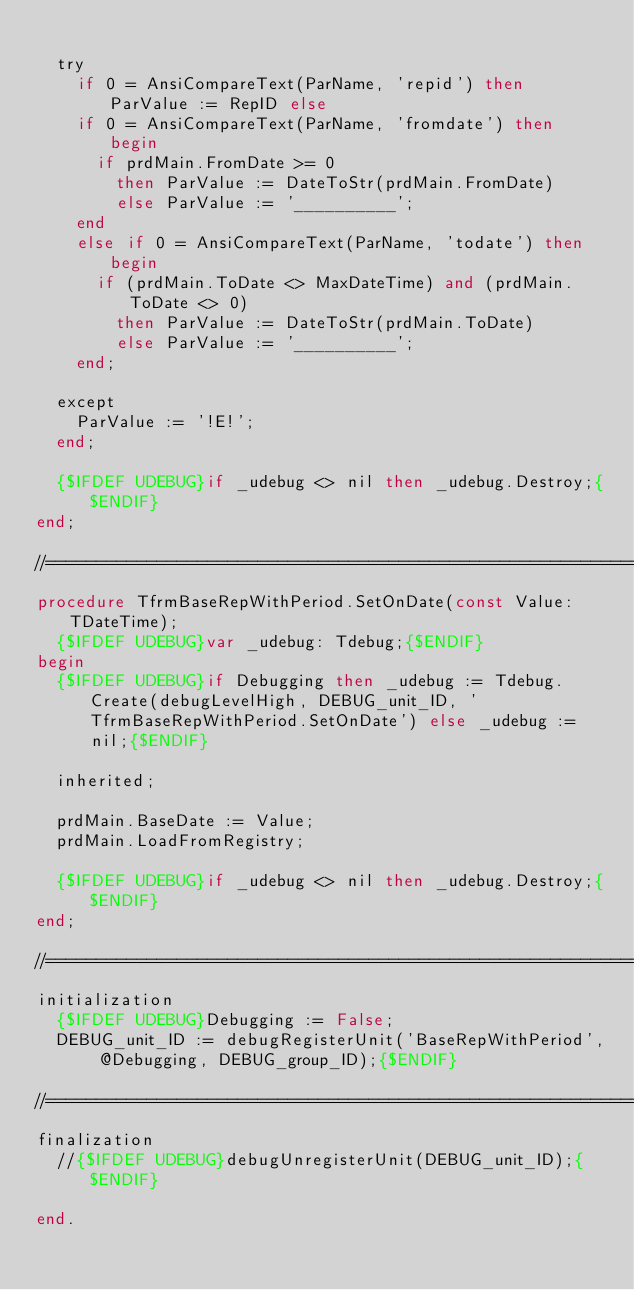Convert code to text. <code><loc_0><loc_0><loc_500><loc_500><_Pascal_>
  try
    if 0 = AnsiCompareText(ParName, 'repid') then ParValue := RepID else
    if 0 = AnsiCompareText(ParName, 'fromdate') then begin
      if prdMain.FromDate >= 0
        then ParValue := DateToStr(prdMain.FromDate)
        else ParValue := '__________';
    end
    else if 0 = AnsiCompareText(ParName, 'todate') then begin
      if (prdMain.ToDate <> MaxDateTime) and (prdMain.ToDate <> 0)
        then ParValue := DateToStr(prdMain.ToDate)
        else ParValue := '__________';
    end;

  except
    ParValue := '!E!';
  end;

  {$IFDEF UDEBUG}if _udebug <> nil then _udebug.Destroy;{$ENDIF}
end;

//==============================================================================================
procedure TfrmBaseRepWithPeriod.SetOnDate(const Value: TDateTime);
  {$IFDEF UDEBUG}var _udebug: Tdebug;{$ENDIF}
begin
  {$IFDEF UDEBUG}if Debugging then _udebug := Tdebug.Create(debugLevelHigh, DEBUG_unit_ID, 'TfrmBaseRepWithPeriod.SetOnDate') else _udebug := nil;{$ENDIF}

  inherited;

  prdMain.BaseDate := Value;
  prdMain.LoadFromRegistry;

  {$IFDEF UDEBUG}if _udebug <> nil then _udebug.Destroy;{$ENDIF}
end;

//==============================================================================================
initialization
  {$IFDEF UDEBUG}Debugging := False;
  DEBUG_unit_ID := debugRegisterUnit('BaseRepWithPeriod', @Debugging, DEBUG_group_ID);{$ENDIF}

//==============================================================================================
finalization
  //{$IFDEF UDEBUG}debugUnregisterUnit(DEBUG_unit_ID);{$ENDIF}

end.
</code> 